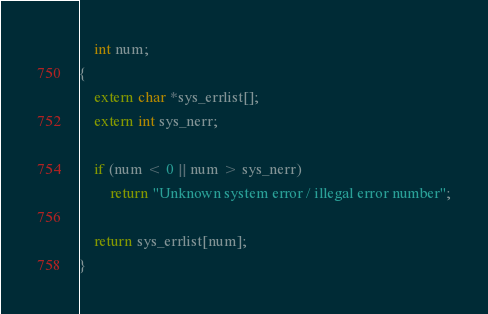Convert code to text. <code><loc_0><loc_0><loc_500><loc_500><_C_>	int num;
{
	extern char *sys_errlist[];
	extern int sys_nerr;

	if (num < 0 || num > sys_nerr)
		return "Unknown system error / illegal error number";

	return sys_errlist[num];
}
</code> 